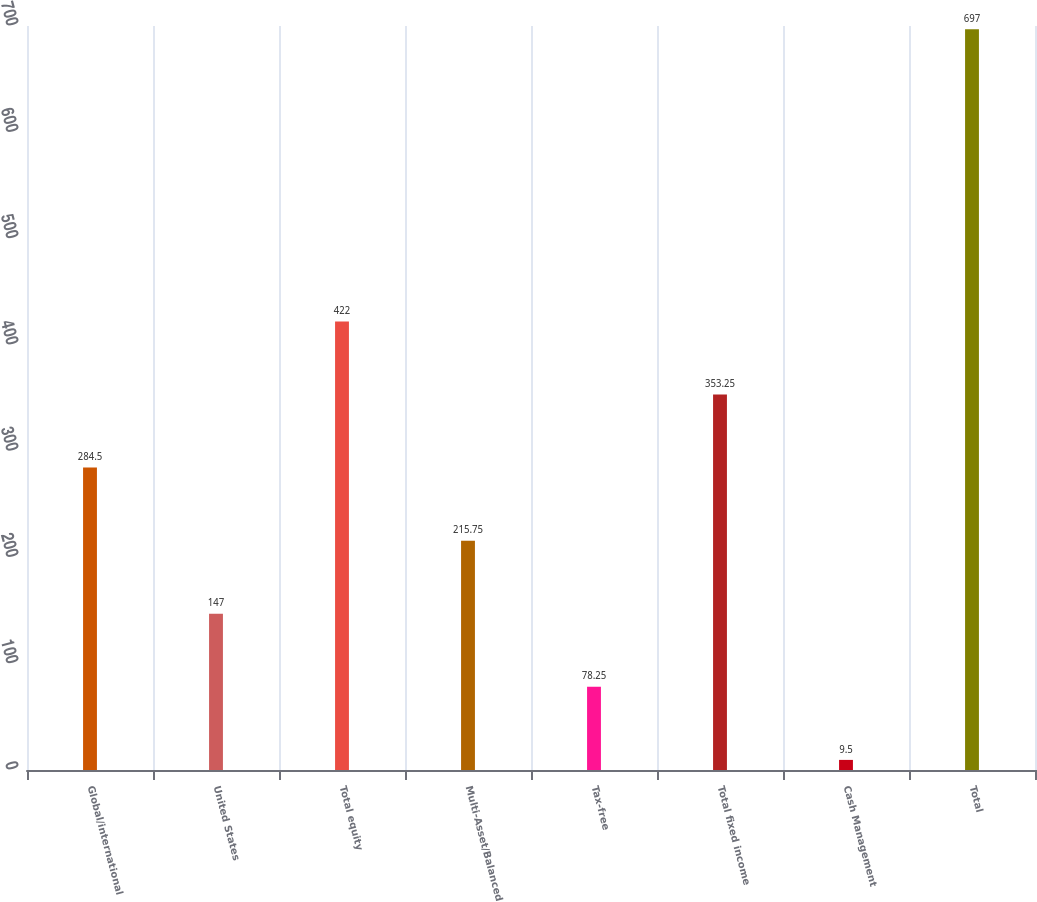Convert chart to OTSL. <chart><loc_0><loc_0><loc_500><loc_500><bar_chart><fcel>Global/international<fcel>United States<fcel>Total equity<fcel>Multi-Asset/Balanced<fcel>Tax-free<fcel>Total fixed income<fcel>Cash Management<fcel>Total<nl><fcel>284.5<fcel>147<fcel>422<fcel>215.75<fcel>78.25<fcel>353.25<fcel>9.5<fcel>697<nl></chart> 